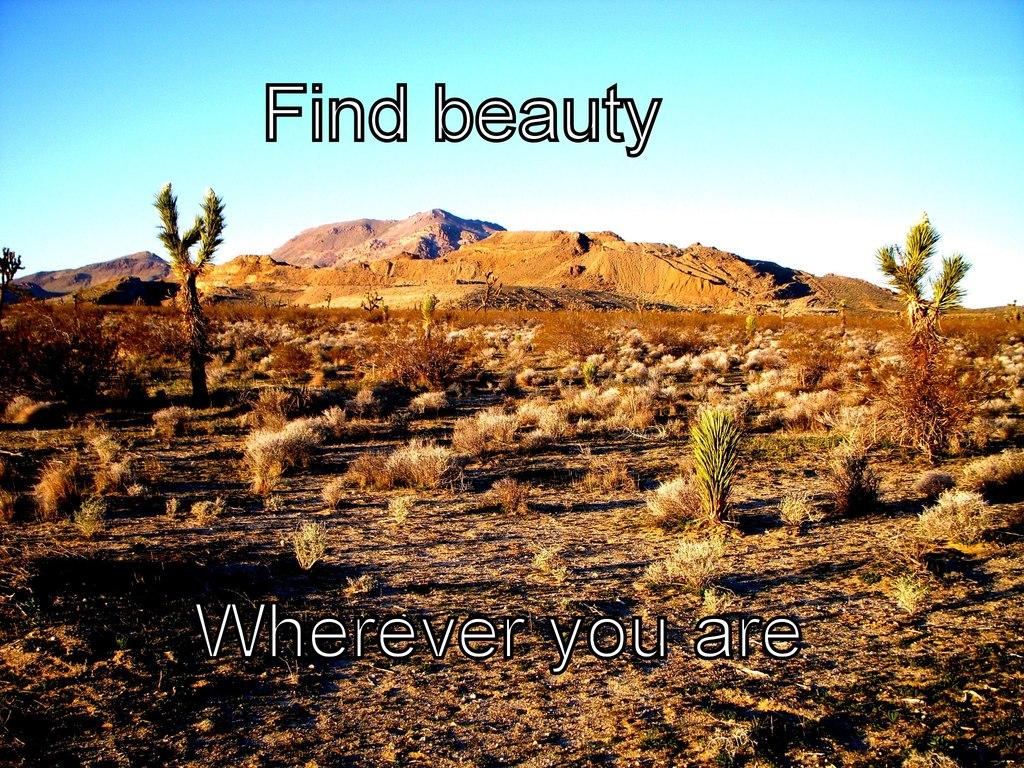What type of vegetation is present at the bottom of the image? There is dry grass at the bottom of the image. What geographical features can be seen in the background of the image? Hills are visible in the background of the image. What is visible at the top of the image? The sky is visible at the top of the image. What type of ground coverings are present in the image? There are stones and sand on the ground in the image. What type of mist can be seen surrounding the hills in the image? There is no mist present in the image; only dry grass, hills, sky, stones, and sand are visible. Can you tell me the title of the image? There is no title provided for the image. 